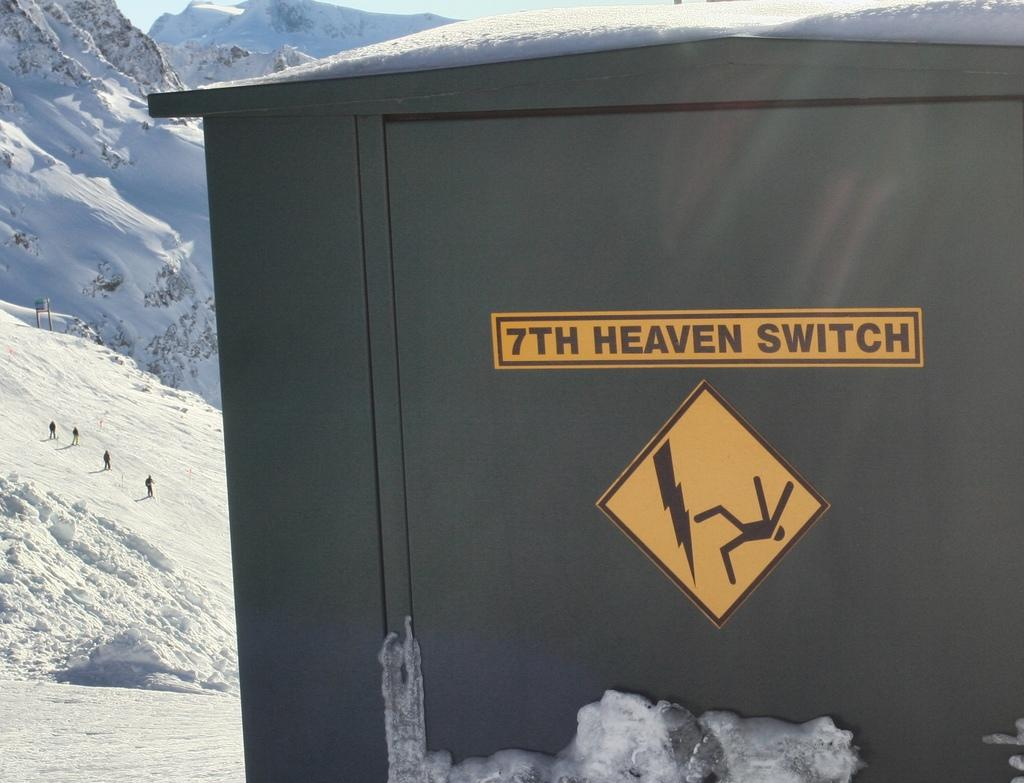<image>
Write a terse but informative summary of the picture. a 7th heaven sign that is yellow among the snow 